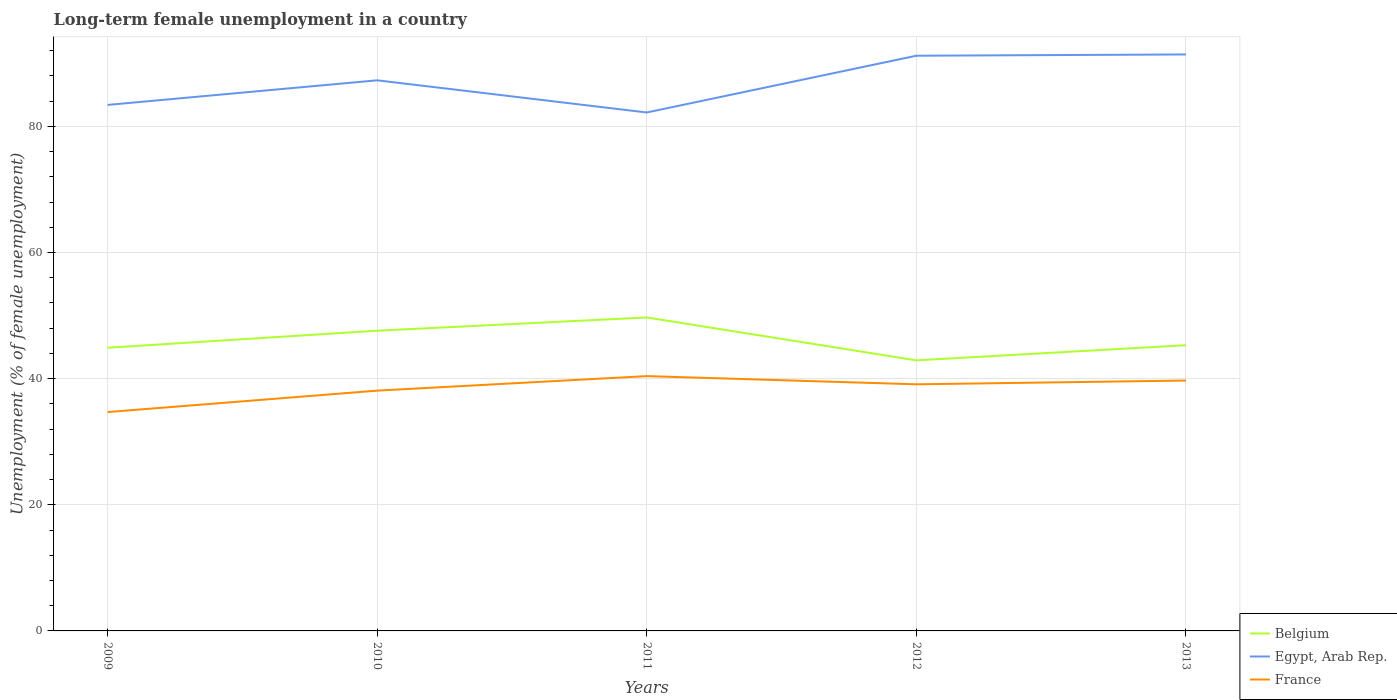How many different coloured lines are there?
Your answer should be very brief. 3. Is the number of lines equal to the number of legend labels?
Make the answer very short. Yes. Across all years, what is the maximum percentage of long-term unemployed female population in Belgium?
Ensure brevity in your answer.  42.9. In which year was the percentage of long-term unemployed female population in Egypt, Arab Rep. maximum?
Offer a very short reply. 2011. What is the difference between the highest and the second highest percentage of long-term unemployed female population in Belgium?
Make the answer very short. 6.8. What is the difference between the highest and the lowest percentage of long-term unemployed female population in Egypt, Arab Rep.?
Provide a succinct answer. 3. Is the percentage of long-term unemployed female population in Egypt, Arab Rep. strictly greater than the percentage of long-term unemployed female population in France over the years?
Your response must be concise. No. How many lines are there?
Offer a terse response. 3. Are the values on the major ticks of Y-axis written in scientific E-notation?
Keep it short and to the point. No. Does the graph contain any zero values?
Your response must be concise. No. Does the graph contain grids?
Ensure brevity in your answer.  Yes. Where does the legend appear in the graph?
Provide a short and direct response. Bottom right. How many legend labels are there?
Provide a succinct answer. 3. What is the title of the graph?
Keep it short and to the point. Long-term female unemployment in a country. Does "World" appear as one of the legend labels in the graph?
Provide a succinct answer. No. What is the label or title of the Y-axis?
Keep it short and to the point. Unemployment (% of female unemployment). What is the Unemployment (% of female unemployment) in Belgium in 2009?
Your answer should be compact. 44.9. What is the Unemployment (% of female unemployment) of Egypt, Arab Rep. in 2009?
Offer a terse response. 83.4. What is the Unemployment (% of female unemployment) of France in 2009?
Your answer should be very brief. 34.7. What is the Unemployment (% of female unemployment) in Belgium in 2010?
Your answer should be compact. 47.6. What is the Unemployment (% of female unemployment) in Egypt, Arab Rep. in 2010?
Your answer should be very brief. 87.3. What is the Unemployment (% of female unemployment) of France in 2010?
Your response must be concise. 38.1. What is the Unemployment (% of female unemployment) in Belgium in 2011?
Your response must be concise. 49.7. What is the Unemployment (% of female unemployment) in Egypt, Arab Rep. in 2011?
Provide a succinct answer. 82.2. What is the Unemployment (% of female unemployment) in France in 2011?
Your response must be concise. 40.4. What is the Unemployment (% of female unemployment) of Belgium in 2012?
Give a very brief answer. 42.9. What is the Unemployment (% of female unemployment) of Egypt, Arab Rep. in 2012?
Offer a terse response. 91.2. What is the Unemployment (% of female unemployment) of France in 2012?
Provide a short and direct response. 39.1. What is the Unemployment (% of female unemployment) of Belgium in 2013?
Offer a very short reply. 45.3. What is the Unemployment (% of female unemployment) in Egypt, Arab Rep. in 2013?
Make the answer very short. 91.4. What is the Unemployment (% of female unemployment) of France in 2013?
Your response must be concise. 39.7. Across all years, what is the maximum Unemployment (% of female unemployment) of Belgium?
Offer a terse response. 49.7. Across all years, what is the maximum Unemployment (% of female unemployment) of Egypt, Arab Rep.?
Offer a terse response. 91.4. Across all years, what is the maximum Unemployment (% of female unemployment) of France?
Give a very brief answer. 40.4. Across all years, what is the minimum Unemployment (% of female unemployment) of Belgium?
Your response must be concise. 42.9. Across all years, what is the minimum Unemployment (% of female unemployment) of Egypt, Arab Rep.?
Offer a very short reply. 82.2. Across all years, what is the minimum Unemployment (% of female unemployment) of France?
Your response must be concise. 34.7. What is the total Unemployment (% of female unemployment) of Belgium in the graph?
Offer a terse response. 230.4. What is the total Unemployment (% of female unemployment) in Egypt, Arab Rep. in the graph?
Make the answer very short. 435.5. What is the total Unemployment (% of female unemployment) of France in the graph?
Give a very brief answer. 192. What is the difference between the Unemployment (% of female unemployment) in Belgium in 2009 and that in 2010?
Provide a succinct answer. -2.7. What is the difference between the Unemployment (% of female unemployment) in Egypt, Arab Rep. in 2009 and that in 2010?
Your answer should be compact. -3.9. What is the difference between the Unemployment (% of female unemployment) of Belgium in 2009 and that in 2011?
Offer a very short reply. -4.8. What is the difference between the Unemployment (% of female unemployment) in Egypt, Arab Rep. in 2009 and that in 2011?
Offer a very short reply. 1.2. What is the difference between the Unemployment (% of female unemployment) of France in 2009 and that in 2011?
Give a very brief answer. -5.7. What is the difference between the Unemployment (% of female unemployment) in Belgium in 2009 and that in 2012?
Provide a short and direct response. 2. What is the difference between the Unemployment (% of female unemployment) of Egypt, Arab Rep. in 2009 and that in 2013?
Provide a short and direct response. -8. What is the difference between the Unemployment (% of female unemployment) of France in 2009 and that in 2013?
Your response must be concise. -5. What is the difference between the Unemployment (% of female unemployment) in France in 2010 and that in 2011?
Make the answer very short. -2.3. What is the difference between the Unemployment (% of female unemployment) in Belgium in 2010 and that in 2012?
Offer a terse response. 4.7. What is the difference between the Unemployment (% of female unemployment) of France in 2010 and that in 2012?
Provide a succinct answer. -1. What is the difference between the Unemployment (% of female unemployment) of Belgium in 2010 and that in 2013?
Keep it short and to the point. 2.3. What is the difference between the Unemployment (% of female unemployment) of Belgium in 2011 and that in 2013?
Ensure brevity in your answer.  4.4. What is the difference between the Unemployment (% of female unemployment) in Belgium in 2012 and that in 2013?
Keep it short and to the point. -2.4. What is the difference between the Unemployment (% of female unemployment) of Egypt, Arab Rep. in 2012 and that in 2013?
Make the answer very short. -0.2. What is the difference between the Unemployment (% of female unemployment) of France in 2012 and that in 2013?
Your answer should be very brief. -0.6. What is the difference between the Unemployment (% of female unemployment) in Belgium in 2009 and the Unemployment (% of female unemployment) in Egypt, Arab Rep. in 2010?
Provide a succinct answer. -42.4. What is the difference between the Unemployment (% of female unemployment) of Egypt, Arab Rep. in 2009 and the Unemployment (% of female unemployment) of France in 2010?
Offer a very short reply. 45.3. What is the difference between the Unemployment (% of female unemployment) in Belgium in 2009 and the Unemployment (% of female unemployment) in Egypt, Arab Rep. in 2011?
Offer a very short reply. -37.3. What is the difference between the Unemployment (% of female unemployment) in Belgium in 2009 and the Unemployment (% of female unemployment) in Egypt, Arab Rep. in 2012?
Offer a terse response. -46.3. What is the difference between the Unemployment (% of female unemployment) of Egypt, Arab Rep. in 2009 and the Unemployment (% of female unemployment) of France in 2012?
Provide a succinct answer. 44.3. What is the difference between the Unemployment (% of female unemployment) in Belgium in 2009 and the Unemployment (% of female unemployment) in Egypt, Arab Rep. in 2013?
Provide a short and direct response. -46.5. What is the difference between the Unemployment (% of female unemployment) of Belgium in 2009 and the Unemployment (% of female unemployment) of France in 2013?
Your response must be concise. 5.2. What is the difference between the Unemployment (% of female unemployment) of Egypt, Arab Rep. in 2009 and the Unemployment (% of female unemployment) of France in 2013?
Ensure brevity in your answer.  43.7. What is the difference between the Unemployment (% of female unemployment) of Belgium in 2010 and the Unemployment (% of female unemployment) of Egypt, Arab Rep. in 2011?
Your answer should be compact. -34.6. What is the difference between the Unemployment (% of female unemployment) in Egypt, Arab Rep. in 2010 and the Unemployment (% of female unemployment) in France in 2011?
Your answer should be compact. 46.9. What is the difference between the Unemployment (% of female unemployment) of Belgium in 2010 and the Unemployment (% of female unemployment) of Egypt, Arab Rep. in 2012?
Make the answer very short. -43.6. What is the difference between the Unemployment (% of female unemployment) of Belgium in 2010 and the Unemployment (% of female unemployment) of France in 2012?
Your answer should be compact. 8.5. What is the difference between the Unemployment (% of female unemployment) in Egypt, Arab Rep. in 2010 and the Unemployment (% of female unemployment) in France in 2012?
Offer a terse response. 48.2. What is the difference between the Unemployment (% of female unemployment) of Belgium in 2010 and the Unemployment (% of female unemployment) of Egypt, Arab Rep. in 2013?
Make the answer very short. -43.8. What is the difference between the Unemployment (% of female unemployment) in Egypt, Arab Rep. in 2010 and the Unemployment (% of female unemployment) in France in 2013?
Offer a terse response. 47.6. What is the difference between the Unemployment (% of female unemployment) in Belgium in 2011 and the Unemployment (% of female unemployment) in Egypt, Arab Rep. in 2012?
Give a very brief answer. -41.5. What is the difference between the Unemployment (% of female unemployment) of Egypt, Arab Rep. in 2011 and the Unemployment (% of female unemployment) of France in 2012?
Your answer should be very brief. 43.1. What is the difference between the Unemployment (% of female unemployment) of Belgium in 2011 and the Unemployment (% of female unemployment) of Egypt, Arab Rep. in 2013?
Make the answer very short. -41.7. What is the difference between the Unemployment (% of female unemployment) of Egypt, Arab Rep. in 2011 and the Unemployment (% of female unemployment) of France in 2013?
Offer a terse response. 42.5. What is the difference between the Unemployment (% of female unemployment) of Belgium in 2012 and the Unemployment (% of female unemployment) of Egypt, Arab Rep. in 2013?
Offer a terse response. -48.5. What is the difference between the Unemployment (% of female unemployment) of Egypt, Arab Rep. in 2012 and the Unemployment (% of female unemployment) of France in 2013?
Keep it short and to the point. 51.5. What is the average Unemployment (% of female unemployment) in Belgium per year?
Offer a terse response. 46.08. What is the average Unemployment (% of female unemployment) in Egypt, Arab Rep. per year?
Your answer should be compact. 87.1. What is the average Unemployment (% of female unemployment) of France per year?
Keep it short and to the point. 38.4. In the year 2009, what is the difference between the Unemployment (% of female unemployment) in Belgium and Unemployment (% of female unemployment) in Egypt, Arab Rep.?
Ensure brevity in your answer.  -38.5. In the year 2009, what is the difference between the Unemployment (% of female unemployment) in Egypt, Arab Rep. and Unemployment (% of female unemployment) in France?
Your answer should be compact. 48.7. In the year 2010, what is the difference between the Unemployment (% of female unemployment) of Belgium and Unemployment (% of female unemployment) of Egypt, Arab Rep.?
Give a very brief answer. -39.7. In the year 2010, what is the difference between the Unemployment (% of female unemployment) in Egypt, Arab Rep. and Unemployment (% of female unemployment) in France?
Make the answer very short. 49.2. In the year 2011, what is the difference between the Unemployment (% of female unemployment) in Belgium and Unemployment (% of female unemployment) in Egypt, Arab Rep.?
Your answer should be very brief. -32.5. In the year 2011, what is the difference between the Unemployment (% of female unemployment) of Egypt, Arab Rep. and Unemployment (% of female unemployment) of France?
Provide a short and direct response. 41.8. In the year 2012, what is the difference between the Unemployment (% of female unemployment) in Belgium and Unemployment (% of female unemployment) in Egypt, Arab Rep.?
Keep it short and to the point. -48.3. In the year 2012, what is the difference between the Unemployment (% of female unemployment) in Belgium and Unemployment (% of female unemployment) in France?
Your answer should be very brief. 3.8. In the year 2012, what is the difference between the Unemployment (% of female unemployment) in Egypt, Arab Rep. and Unemployment (% of female unemployment) in France?
Offer a very short reply. 52.1. In the year 2013, what is the difference between the Unemployment (% of female unemployment) of Belgium and Unemployment (% of female unemployment) of Egypt, Arab Rep.?
Provide a short and direct response. -46.1. In the year 2013, what is the difference between the Unemployment (% of female unemployment) in Belgium and Unemployment (% of female unemployment) in France?
Offer a terse response. 5.6. In the year 2013, what is the difference between the Unemployment (% of female unemployment) of Egypt, Arab Rep. and Unemployment (% of female unemployment) of France?
Your answer should be very brief. 51.7. What is the ratio of the Unemployment (% of female unemployment) of Belgium in 2009 to that in 2010?
Your answer should be compact. 0.94. What is the ratio of the Unemployment (% of female unemployment) of Egypt, Arab Rep. in 2009 to that in 2010?
Make the answer very short. 0.96. What is the ratio of the Unemployment (% of female unemployment) of France in 2009 to that in 2010?
Your answer should be compact. 0.91. What is the ratio of the Unemployment (% of female unemployment) of Belgium in 2009 to that in 2011?
Keep it short and to the point. 0.9. What is the ratio of the Unemployment (% of female unemployment) in Egypt, Arab Rep. in 2009 to that in 2011?
Your answer should be very brief. 1.01. What is the ratio of the Unemployment (% of female unemployment) in France in 2009 to that in 2011?
Provide a short and direct response. 0.86. What is the ratio of the Unemployment (% of female unemployment) of Belgium in 2009 to that in 2012?
Provide a short and direct response. 1.05. What is the ratio of the Unemployment (% of female unemployment) of Egypt, Arab Rep. in 2009 to that in 2012?
Offer a very short reply. 0.91. What is the ratio of the Unemployment (% of female unemployment) in France in 2009 to that in 2012?
Make the answer very short. 0.89. What is the ratio of the Unemployment (% of female unemployment) in Belgium in 2009 to that in 2013?
Offer a terse response. 0.99. What is the ratio of the Unemployment (% of female unemployment) of Egypt, Arab Rep. in 2009 to that in 2013?
Your answer should be compact. 0.91. What is the ratio of the Unemployment (% of female unemployment) of France in 2009 to that in 2013?
Provide a short and direct response. 0.87. What is the ratio of the Unemployment (% of female unemployment) of Belgium in 2010 to that in 2011?
Keep it short and to the point. 0.96. What is the ratio of the Unemployment (% of female unemployment) in Egypt, Arab Rep. in 2010 to that in 2011?
Offer a terse response. 1.06. What is the ratio of the Unemployment (% of female unemployment) of France in 2010 to that in 2011?
Keep it short and to the point. 0.94. What is the ratio of the Unemployment (% of female unemployment) of Belgium in 2010 to that in 2012?
Make the answer very short. 1.11. What is the ratio of the Unemployment (% of female unemployment) in Egypt, Arab Rep. in 2010 to that in 2012?
Make the answer very short. 0.96. What is the ratio of the Unemployment (% of female unemployment) of France in 2010 to that in 2012?
Offer a terse response. 0.97. What is the ratio of the Unemployment (% of female unemployment) of Belgium in 2010 to that in 2013?
Provide a short and direct response. 1.05. What is the ratio of the Unemployment (% of female unemployment) of Egypt, Arab Rep. in 2010 to that in 2013?
Keep it short and to the point. 0.96. What is the ratio of the Unemployment (% of female unemployment) in France in 2010 to that in 2013?
Offer a very short reply. 0.96. What is the ratio of the Unemployment (% of female unemployment) in Belgium in 2011 to that in 2012?
Ensure brevity in your answer.  1.16. What is the ratio of the Unemployment (% of female unemployment) in Egypt, Arab Rep. in 2011 to that in 2012?
Offer a very short reply. 0.9. What is the ratio of the Unemployment (% of female unemployment) of France in 2011 to that in 2012?
Your response must be concise. 1.03. What is the ratio of the Unemployment (% of female unemployment) of Belgium in 2011 to that in 2013?
Your response must be concise. 1.1. What is the ratio of the Unemployment (% of female unemployment) of Egypt, Arab Rep. in 2011 to that in 2013?
Provide a short and direct response. 0.9. What is the ratio of the Unemployment (% of female unemployment) in France in 2011 to that in 2013?
Keep it short and to the point. 1.02. What is the ratio of the Unemployment (% of female unemployment) of Belgium in 2012 to that in 2013?
Ensure brevity in your answer.  0.95. What is the ratio of the Unemployment (% of female unemployment) of France in 2012 to that in 2013?
Your response must be concise. 0.98. What is the difference between the highest and the second highest Unemployment (% of female unemployment) of Belgium?
Offer a terse response. 2.1. What is the difference between the highest and the second highest Unemployment (% of female unemployment) in Egypt, Arab Rep.?
Your response must be concise. 0.2. What is the difference between the highest and the lowest Unemployment (% of female unemployment) of Belgium?
Your response must be concise. 6.8. 